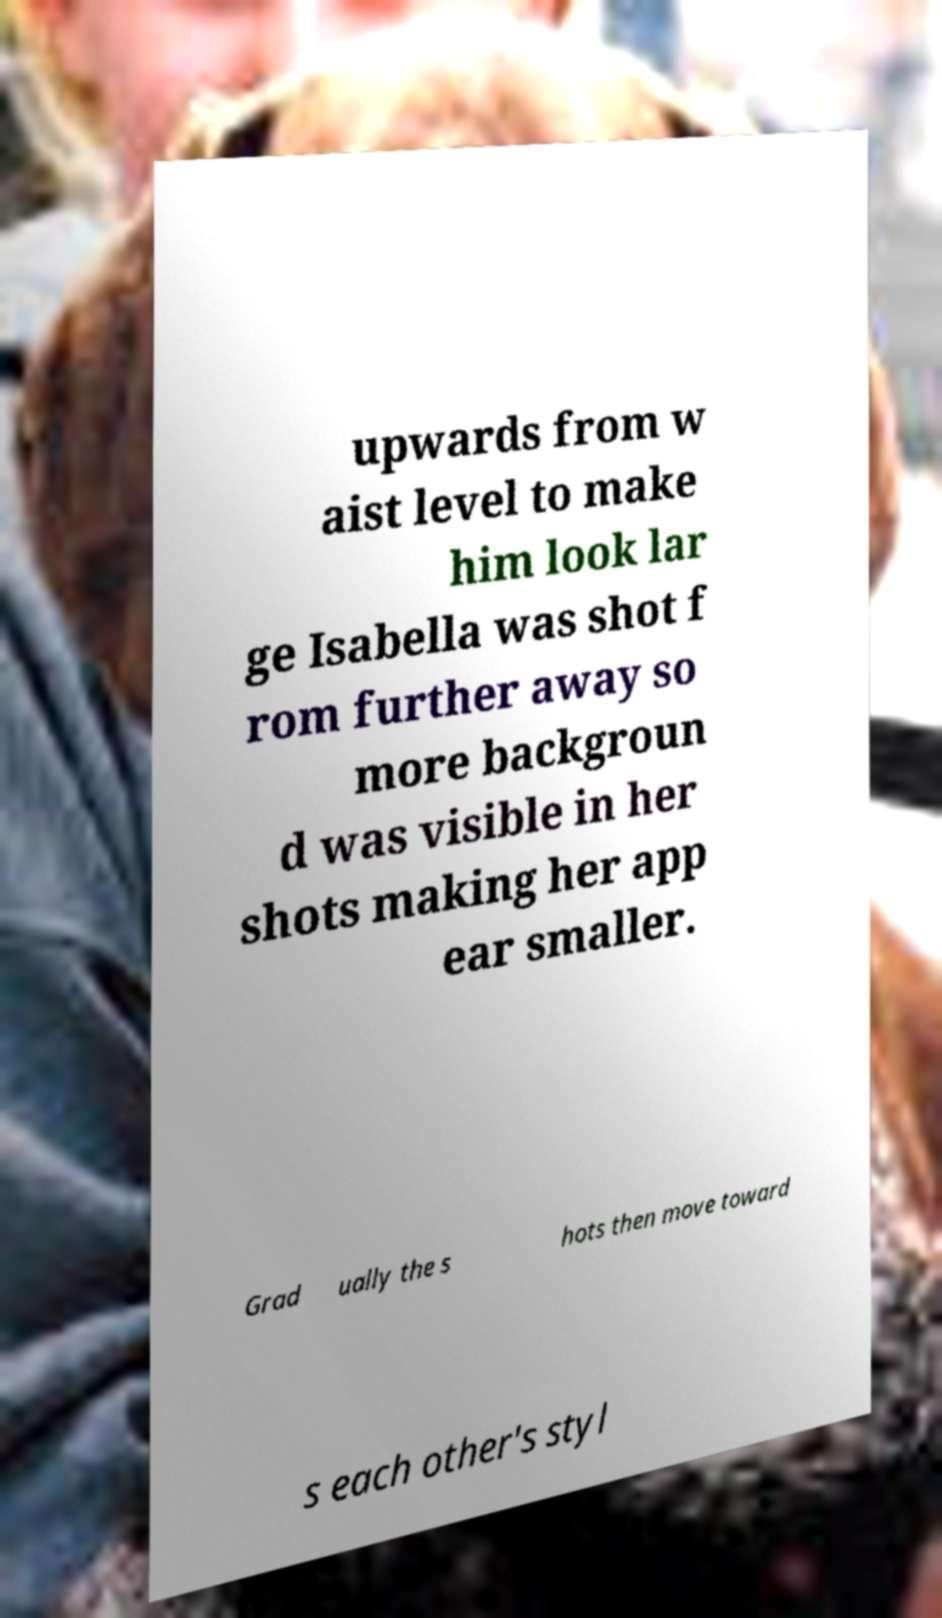Please identify and transcribe the text found in this image. upwards from w aist level to make him look lar ge Isabella was shot f rom further away so more backgroun d was visible in her shots making her app ear smaller. Grad ually the s hots then move toward s each other's styl 